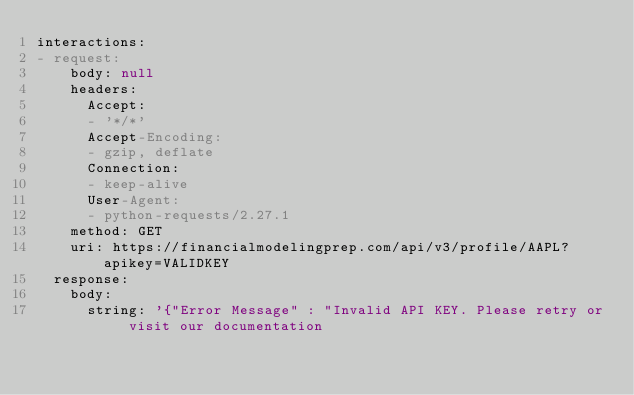Convert code to text. <code><loc_0><loc_0><loc_500><loc_500><_YAML_>interactions:
- request:
    body: null
    headers:
      Accept:
      - '*/*'
      Accept-Encoding:
      - gzip, deflate
      Connection:
      - keep-alive
      User-Agent:
      - python-requests/2.27.1
    method: GET
    uri: https://financialmodelingprep.com/api/v3/profile/AAPL?apikey=VALIDKEY
  response:
    body:
      string: '{"Error Message" : "Invalid API KEY. Please retry or visit our documentation</code> 